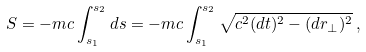<formula> <loc_0><loc_0><loc_500><loc_500>S = - m c \int _ { s _ { 1 } } ^ { s _ { 2 } } d s = - m c \int _ { s _ { 1 } } ^ { s _ { 2 } } \sqrt { c ^ { 2 } ( d t ) ^ { 2 } - ( d { r } _ { \perp } ) ^ { 2 } } \, ,</formula> 